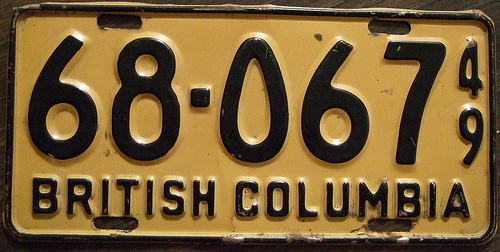<image>
Can you confirm if the number is next to the letter? No. The number is not positioned next to the letter. They are located in different areas of the scene. Is the six in front of the letter? No. The six is not in front of the letter. The spatial positioning shows a different relationship between these objects. 